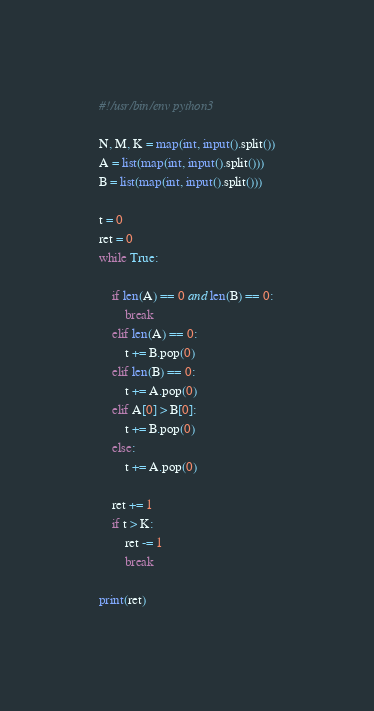<code> <loc_0><loc_0><loc_500><loc_500><_Python_>#!/usr/bin/env python3

N, M, K = map(int, input().split())
A = list(map(int, input().split()))
B = list(map(int, input().split()))

t = 0
ret = 0
while True:

    if len(A) == 0 and len(B) == 0:
        break
    elif len(A) == 0:
        t += B.pop(0)
    elif len(B) == 0:
        t += A.pop(0)
    elif A[0] > B[0]:
        t += B.pop(0)
    else:
        t += A.pop(0)

    ret += 1
    if t > K:
        ret -= 1
        break

print(ret)
</code> 